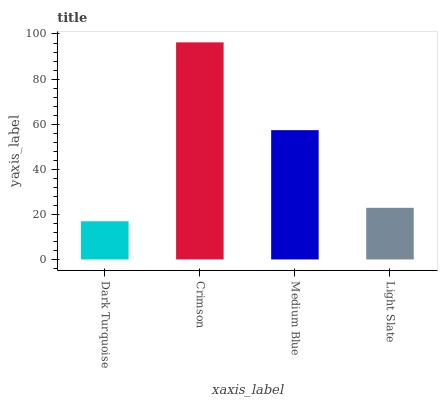Is Dark Turquoise the minimum?
Answer yes or no. Yes. Is Crimson the maximum?
Answer yes or no. Yes. Is Medium Blue the minimum?
Answer yes or no. No. Is Medium Blue the maximum?
Answer yes or no. No. Is Crimson greater than Medium Blue?
Answer yes or no. Yes. Is Medium Blue less than Crimson?
Answer yes or no. Yes. Is Medium Blue greater than Crimson?
Answer yes or no. No. Is Crimson less than Medium Blue?
Answer yes or no. No. Is Medium Blue the high median?
Answer yes or no. Yes. Is Light Slate the low median?
Answer yes or no. Yes. Is Crimson the high median?
Answer yes or no. No. Is Crimson the low median?
Answer yes or no. No. 